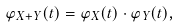Convert formula to latex. <formula><loc_0><loc_0><loc_500><loc_500>\varphi _ { X + Y } ( t ) = \varphi _ { X } ( t ) \cdot \varphi _ { Y } ( t ) ,</formula> 